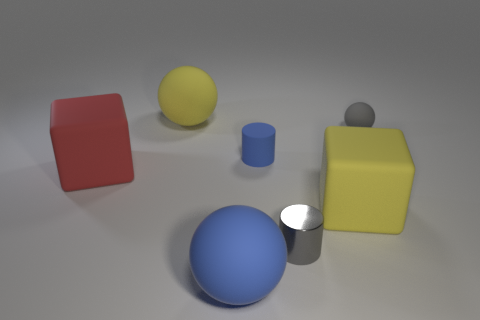Subtract all small gray balls. How many balls are left? 2 Add 1 large purple shiny cylinders. How many objects exist? 8 Subtract 1 yellow spheres. How many objects are left? 6 Subtract all balls. How many objects are left? 4 Subtract all yellow matte balls. Subtract all cylinders. How many objects are left? 4 Add 2 yellow spheres. How many yellow spheres are left? 3 Add 4 yellow rubber spheres. How many yellow rubber spheres exist? 5 